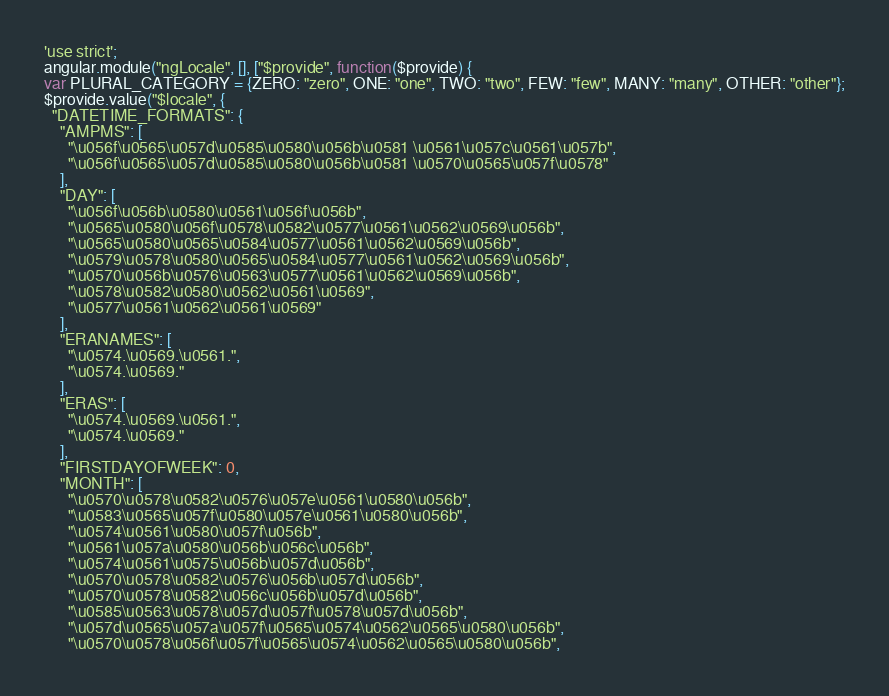<code> <loc_0><loc_0><loc_500><loc_500><_JavaScript_>'use strict';
angular.module("ngLocale", [], ["$provide", function($provide) {
var PLURAL_CATEGORY = {ZERO: "zero", ONE: "one", TWO: "two", FEW: "few", MANY: "many", OTHER: "other"};
$provide.value("$locale", {
  "DATETIME_FORMATS": {
    "AMPMS": [
      "\u056f\u0565\u057d\u0585\u0580\u056b\u0581 \u0561\u057c\u0561\u057b",
      "\u056f\u0565\u057d\u0585\u0580\u056b\u0581 \u0570\u0565\u057f\u0578"
    ],
    "DAY": [
      "\u056f\u056b\u0580\u0561\u056f\u056b",
      "\u0565\u0580\u056f\u0578\u0582\u0577\u0561\u0562\u0569\u056b",
      "\u0565\u0580\u0565\u0584\u0577\u0561\u0562\u0569\u056b",
      "\u0579\u0578\u0580\u0565\u0584\u0577\u0561\u0562\u0569\u056b",
      "\u0570\u056b\u0576\u0563\u0577\u0561\u0562\u0569\u056b",
      "\u0578\u0582\u0580\u0562\u0561\u0569",
      "\u0577\u0561\u0562\u0561\u0569"
    ],
    "ERANAMES": [
      "\u0574.\u0569.\u0561.",
      "\u0574.\u0569."
    ],
    "ERAS": [
      "\u0574.\u0569.\u0561.",
      "\u0574.\u0569."
    ],
    "FIRSTDAYOFWEEK": 0,
    "MONTH": [
      "\u0570\u0578\u0582\u0576\u057e\u0561\u0580\u056b",
      "\u0583\u0565\u057f\u0580\u057e\u0561\u0580\u056b",
      "\u0574\u0561\u0580\u057f\u056b",
      "\u0561\u057a\u0580\u056b\u056c\u056b",
      "\u0574\u0561\u0575\u056b\u057d\u056b",
      "\u0570\u0578\u0582\u0576\u056b\u057d\u056b",
      "\u0570\u0578\u0582\u056c\u056b\u057d\u056b",
      "\u0585\u0563\u0578\u057d\u057f\u0578\u057d\u056b",
      "\u057d\u0565\u057a\u057f\u0565\u0574\u0562\u0565\u0580\u056b",
      "\u0570\u0578\u056f\u057f\u0565\u0574\u0562\u0565\u0580\u056b",</code> 